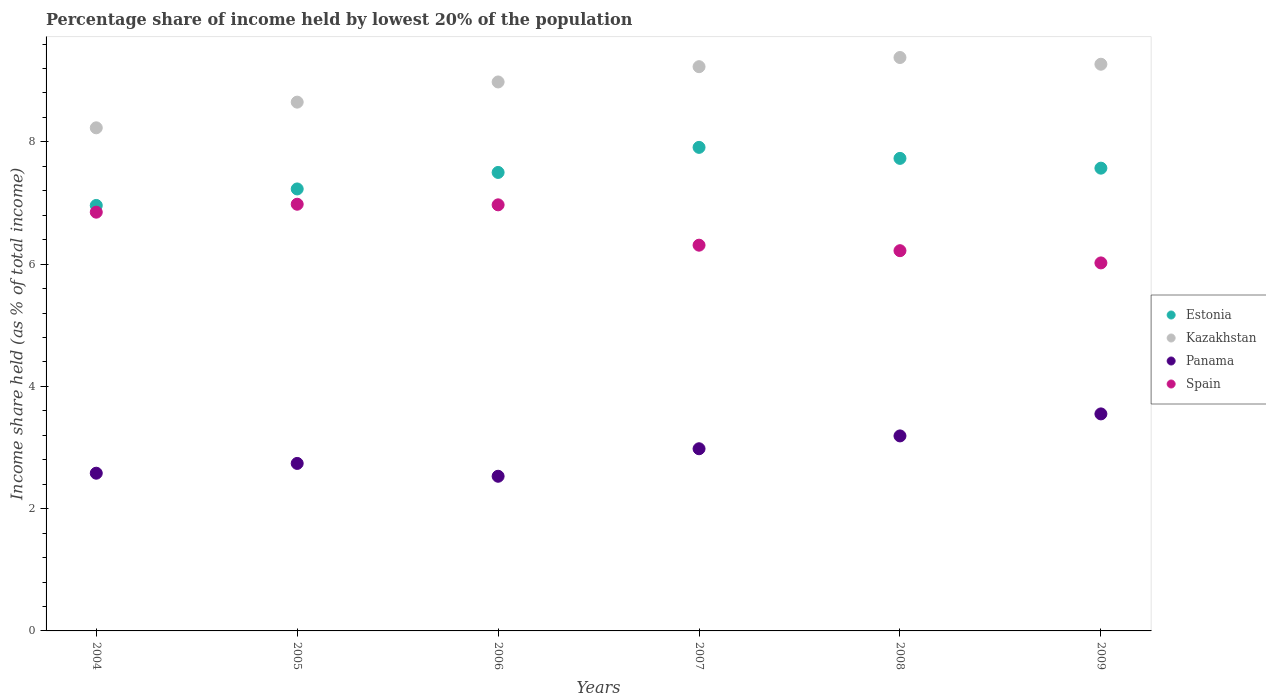Is the number of dotlines equal to the number of legend labels?
Offer a very short reply. Yes. What is the percentage share of income held by lowest 20% of the population in Spain in 2007?
Provide a succinct answer. 6.31. Across all years, what is the maximum percentage share of income held by lowest 20% of the population in Estonia?
Offer a very short reply. 7.91. Across all years, what is the minimum percentage share of income held by lowest 20% of the population in Spain?
Offer a terse response. 6.02. What is the total percentage share of income held by lowest 20% of the population in Estonia in the graph?
Your answer should be compact. 44.9. What is the difference between the percentage share of income held by lowest 20% of the population in Spain in 2004 and that in 2008?
Your answer should be compact. 0.63. What is the difference between the percentage share of income held by lowest 20% of the population in Kazakhstan in 2006 and the percentage share of income held by lowest 20% of the population in Estonia in 2004?
Give a very brief answer. 2.02. What is the average percentage share of income held by lowest 20% of the population in Kazakhstan per year?
Give a very brief answer. 8.96. In the year 2006, what is the difference between the percentage share of income held by lowest 20% of the population in Estonia and percentage share of income held by lowest 20% of the population in Panama?
Your answer should be very brief. 4.97. In how many years, is the percentage share of income held by lowest 20% of the population in Estonia greater than 5.2 %?
Provide a short and direct response. 6. What is the ratio of the percentage share of income held by lowest 20% of the population in Spain in 2005 to that in 2009?
Make the answer very short. 1.16. Is the difference between the percentage share of income held by lowest 20% of the population in Estonia in 2005 and 2008 greater than the difference between the percentage share of income held by lowest 20% of the population in Panama in 2005 and 2008?
Give a very brief answer. No. What is the difference between the highest and the second highest percentage share of income held by lowest 20% of the population in Panama?
Offer a terse response. 0.36. What is the difference between the highest and the lowest percentage share of income held by lowest 20% of the population in Panama?
Provide a succinct answer. 1.02. In how many years, is the percentage share of income held by lowest 20% of the population in Kazakhstan greater than the average percentage share of income held by lowest 20% of the population in Kazakhstan taken over all years?
Your response must be concise. 4. Is it the case that in every year, the sum of the percentage share of income held by lowest 20% of the population in Kazakhstan and percentage share of income held by lowest 20% of the population in Spain  is greater than the sum of percentage share of income held by lowest 20% of the population in Estonia and percentage share of income held by lowest 20% of the population in Panama?
Make the answer very short. Yes. Is it the case that in every year, the sum of the percentage share of income held by lowest 20% of the population in Panama and percentage share of income held by lowest 20% of the population in Kazakhstan  is greater than the percentage share of income held by lowest 20% of the population in Estonia?
Your answer should be compact. Yes. Does the percentage share of income held by lowest 20% of the population in Estonia monotonically increase over the years?
Ensure brevity in your answer.  No. Is the percentage share of income held by lowest 20% of the population in Kazakhstan strictly greater than the percentage share of income held by lowest 20% of the population in Panama over the years?
Your answer should be very brief. Yes. How many dotlines are there?
Ensure brevity in your answer.  4. How many years are there in the graph?
Offer a very short reply. 6. Are the values on the major ticks of Y-axis written in scientific E-notation?
Give a very brief answer. No. Does the graph contain any zero values?
Your answer should be very brief. No. Does the graph contain grids?
Give a very brief answer. No. How many legend labels are there?
Your response must be concise. 4. What is the title of the graph?
Keep it short and to the point. Percentage share of income held by lowest 20% of the population. Does "Macedonia" appear as one of the legend labels in the graph?
Give a very brief answer. No. What is the label or title of the X-axis?
Your response must be concise. Years. What is the label or title of the Y-axis?
Your answer should be compact. Income share held (as % of total income). What is the Income share held (as % of total income) of Estonia in 2004?
Offer a very short reply. 6.96. What is the Income share held (as % of total income) of Kazakhstan in 2004?
Provide a short and direct response. 8.23. What is the Income share held (as % of total income) in Panama in 2004?
Offer a very short reply. 2.58. What is the Income share held (as % of total income) of Spain in 2004?
Offer a terse response. 6.85. What is the Income share held (as % of total income) in Estonia in 2005?
Your response must be concise. 7.23. What is the Income share held (as % of total income) in Kazakhstan in 2005?
Ensure brevity in your answer.  8.65. What is the Income share held (as % of total income) in Panama in 2005?
Your answer should be compact. 2.74. What is the Income share held (as % of total income) of Spain in 2005?
Your response must be concise. 6.98. What is the Income share held (as % of total income) in Kazakhstan in 2006?
Keep it short and to the point. 8.98. What is the Income share held (as % of total income) of Panama in 2006?
Your response must be concise. 2.53. What is the Income share held (as % of total income) of Spain in 2006?
Provide a succinct answer. 6.97. What is the Income share held (as % of total income) in Estonia in 2007?
Your answer should be compact. 7.91. What is the Income share held (as % of total income) in Kazakhstan in 2007?
Your answer should be compact. 9.23. What is the Income share held (as % of total income) in Panama in 2007?
Ensure brevity in your answer.  2.98. What is the Income share held (as % of total income) in Spain in 2007?
Offer a terse response. 6.31. What is the Income share held (as % of total income) in Estonia in 2008?
Offer a terse response. 7.73. What is the Income share held (as % of total income) of Kazakhstan in 2008?
Give a very brief answer. 9.38. What is the Income share held (as % of total income) of Panama in 2008?
Make the answer very short. 3.19. What is the Income share held (as % of total income) in Spain in 2008?
Your answer should be compact. 6.22. What is the Income share held (as % of total income) of Estonia in 2009?
Ensure brevity in your answer.  7.57. What is the Income share held (as % of total income) in Kazakhstan in 2009?
Make the answer very short. 9.27. What is the Income share held (as % of total income) in Panama in 2009?
Offer a very short reply. 3.55. What is the Income share held (as % of total income) in Spain in 2009?
Your answer should be compact. 6.02. Across all years, what is the maximum Income share held (as % of total income) of Estonia?
Give a very brief answer. 7.91. Across all years, what is the maximum Income share held (as % of total income) of Kazakhstan?
Your answer should be very brief. 9.38. Across all years, what is the maximum Income share held (as % of total income) in Panama?
Make the answer very short. 3.55. Across all years, what is the maximum Income share held (as % of total income) of Spain?
Give a very brief answer. 6.98. Across all years, what is the minimum Income share held (as % of total income) in Estonia?
Keep it short and to the point. 6.96. Across all years, what is the minimum Income share held (as % of total income) in Kazakhstan?
Offer a terse response. 8.23. Across all years, what is the minimum Income share held (as % of total income) in Panama?
Offer a terse response. 2.53. Across all years, what is the minimum Income share held (as % of total income) in Spain?
Your answer should be compact. 6.02. What is the total Income share held (as % of total income) of Estonia in the graph?
Provide a short and direct response. 44.9. What is the total Income share held (as % of total income) in Kazakhstan in the graph?
Make the answer very short. 53.74. What is the total Income share held (as % of total income) of Panama in the graph?
Provide a succinct answer. 17.57. What is the total Income share held (as % of total income) in Spain in the graph?
Provide a succinct answer. 39.35. What is the difference between the Income share held (as % of total income) in Estonia in 2004 and that in 2005?
Ensure brevity in your answer.  -0.27. What is the difference between the Income share held (as % of total income) of Kazakhstan in 2004 and that in 2005?
Keep it short and to the point. -0.42. What is the difference between the Income share held (as % of total income) in Panama in 2004 and that in 2005?
Your response must be concise. -0.16. What is the difference between the Income share held (as % of total income) of Spain in 2004 and that in 2005?
Provide a succinct answer. -0.13. What is the difference between the Income share held (as % of total income) of Estonia in 2004 and that in 2006?
Provide a succinct answer. -0.54. What is the difference between the Income share held (as % of total income) of Kazakhstan in 2004 and that in 2006?
Keep it short and to the point. -0.75. What is the difference between the Income share held (as % of total income) in Spain in 2004 and that in 2006?
Ensure brevity in your answer.  -0.12. What is the difference between the Income share held (as % of total income) in Estonia in 2004 and that in 2007?
Ensure brevity in your answer.  -0.95. What is the difference between the Income share held (as % of total income) of Kazakhstan in 2004 and that in 2007?
Provide a succinct answer. -1. What is the difference between the Income share held (as % of total income) in Spain in 2004 and that in 2007?
Keep it short and to the point. 0.54. What is the difference between the Income share held (as % of total income) of Estonia in 2004 and that in 2008?
Provide a succinct answer. -0.77. What is the difference between the Income share held (as % of total income) of Kazakhstan in 2004 and that in 2008?
Ensure brevity in your answer.  -1.15. What is the difference between the Income share held (as % of total income) in Panama in 2004 and that in 2008?
Offer a terse response. -0.61. What is the difference between the Income share held (as % of total income) of Spain in 2004 and that in 2008?
Offer a very short reply. 0.63. What is the difference between the Income share held (as % of total income) in Estonia in 2004 and that in 2009?
Your response must be concise. -0.61. What is the difference between the Income share held (as % of total income) of Kazakhstan in 2004 and that in 2009?
Keep it short and to the point. -1.04. What is the difference between the Income share held (as % of total income) in Panama in 2004 and that in 2009?
Provide a succinct answer. -0.97. What is the difference between the Income share held (as % of total income) in Spain in 2004 and that in 2009?
Provide a short and direct response. 0.83. What is the difference between the Income share held (as % of total income) of Estonia in 2005 and that in 2006?
Provide a short and direct response. -0.27. What is the difference between the Income share held (as % of total income) of Kazakhstan in 2005 and that in 2006?
Make the answer very short. -0.33. What is the difference between the Income share held (as % of total income) in Panama in 2005 and that in 2006?
Your answer should be compact. 0.21. What is the difference between the Income share held (as % of total income) of Estonia in 2005 and that in 2007?
Your answer should be very brief. -0.68. What is the difference between the Income share held (as % of total income) in Kazakhstan in 2005 and that in 2007?
Your answer should be very brief. -0.58. What is the difference between the Income share held (as % of total income) of Panama in 2005 and that in 2007?
Ensure brevity in your answer.  -0.24. What is the difference between the Income share held (as % of total income) of Spain in 2005 and that in 2007?
Provide a succinct answer. 0.67. What is the difference between the Income share held (as % of total income) in Kazakhstan in 2005 and that in 2008?
Give a very brief answer. -0.73. What is the difference between the Income share held (as % of total income) of Panama in 2005 and that in 2008?
Give a very brief answer. -0.45. What is the difference between the Income share held (as % of total income) in Spain in 2005 and that in 2008?
Ensure brevity in your answer.  0.76. What is the difference between the Income share held (as % of total income) in Estonia in 2005 and that in 2009?
Your response must be concise. -0.34. What is the difference between the Income share held (as % of total income) in Kazakhstan in 2005 and that in 2009?
Your answer should be compact. -0.62. What is the difference between the Income share held (as % of total income) of Panama in 2005 and that in 2009?
Offer a very short reply. -0.81. What is the difference between the Income share held (as % of total income) of Spain in 2005 and that in 2009?
Offer a very short reply. 0.96. What is the difference between the Income share held (as % of total income) in Estonia in 2006 and that in 2007?
Make the answer very short. -0.41. What is the difference between the Income share held (as % of total income) of Panama in 2006 and that in 2007?
Offer a terse response. -0.45. What is the difference between the Income share held (as % of total income) of Spain in 2006 and that in 2007?
Your response must be concise. 0.66. What is the difference between the Income share held (as % of total income) in Estonia in 2006 and that in 2008?
Your answer should be compact. -0.23. What is the difference between the Income share held (as % of total income) of Kazakhstan in 2006 and that in 2008?
Offer a very short reply. -0.4. What is the difference between the Income share held (as % of total income) of Panama in 2006 and that in 2008?
Ensure brevity in your answer.  -0.66. What is the difference between the Income share held (as % of total income) of Estonia in 2006 and that in 2009?
Keep it short and to the point. -0.07. What is the difference between the Income share held (as % of total income) of Kazakhstan in 2006 and that in 2009?
Offer a terse response. -0.29. What is the difference between the Income share held (as % of total income) in Panama in 2006 and that in 2009?
Provide a short and direct response. -1.02. What is the difference between the Income share held (as % of total income) in Spain in 2006 and that in 2009?
Offer a very short reply. 0.95. What is the difference between the Income share held (as % of total income) of Estonia in 2007 and that in 2008?
Provide a short and direct response. 0.18. What is the difference between the Income share held (as % of total income) in Panama in 2007 and that in 2008?
Offer a terse response. -0.21. What is the difference between the Income share held (as % of total income) of Spain in 2007 and that in 2008?
Offer a very short reply. 0.09. What is the difference between the Income share held (as % of total income) in Estonia in 2007 and that in 2009?
Keep it short and to the point. 0.34. What is the difference between the Income share held (as % of total income) of Kazakhstan in 2007 and that in 2009?
Make the answer very short. -0.04. What is the difference between the Income share held (as % of total income) of Panama in 2007 and that in 2009?
Provide a succinct answer. -0.57. What is the difference between the Income share held (as % of total income) of Spain in 2007 and that in 2009?
Provide a succinct answer. 0.29. What is the difference between the Income share held (as % of total income) in Estonia in 2008 and that in 2009?
Offer a very short reply. 0.16. What is the difference between the Income share held (as % of total income) of Kazakhstan in 2008 and that in 2009?
Keep it short and to the point. 0.11. What is the difference between the Income share held (as % of total income) in Panama in 2008 and that in 2009?
Keep it short and to the point. -0.36. What is the difference between the Income share held (as % of total income) in Estonia in 2004 and the Income share held (as % of total income) in Kazakhstan in 2005?
Your response must be concise. -1.69. What is the difference between the Income share held (as % of total income) of Estonia in 2004 and the Income share held (as % of total income) of Panama in 2005?
Your answer should be compact. 4.22. What is the difference between the Income share held (as % of total income) of Estonia in 2004 and the Income share held (as % of total income) of Spain in 2005?
Give a very brief answer. -0.02. What is the difference between the Income share held (as % of total income) in Kazakhstan in 2004 and the Income share held (as % of total income) in Panama in 2005?
Give a very brief answer. 5.49. What is the difference between the Income share held (as % of total income) of Panama in 2004 and the Income share held (as % of total income) of Spain in 2005?
Give a very brief answer. -4.4. What is the difference between the Income share held (as % of total income) in Estonia in 2004 and the Income share held (as % of total income) in Kazakhstan in 2006?
Give a very brief answer. -2.02. What is the difference between the Income share held (as % of total income) in Estonia in 2004 and the Income share held (as % of total income) in Panama in 2006?
Your response must be concise. 4.43. What is the difference between the Income share held (as % of total income) in Estonia in 2004 and the Income share held (as % of total income) in Spain in 2006?
Provide a succinct answer. -0.01. What is the difference between the Income share held (as % of total income) in Kazakhstan in 2004 and the Income share held (as % of total income) in Panama in 2006?
Your response must be concise. 5.7. What is the difference between the Income share held (as % of total income) of Kazakhstan in 2004 and the Income share held (as % of total income) of Spain in 2006?
Keep it short and to the point. 1.26. What is the difference between the Income share held (as % of total income) in Panama in 2004 and the Income share held (as % of total income) in Spain in 2006?
Provide a succinct answer. -4.39. What is the difference between the Income share held (as % of total income) in Estonia in 2004 and the Income share held (as % of total income) in Kazakhstan in 2007?
Your answer should be compact. -2.27. What is the difference between the Income share held (as % of total income) of Estonia in 2004 and the Income share held (as % of total income) of Panama in 2007?
Offer a terse response. 3.98. What is the difference between the Income share held (as % of total income) in Estonia in 2004 and the Income share held (as % of total income) in Spain in 2007?
Offer a terse response. 0.65. What is the difference between the Income share held (as % of total income) in Kazakhstan in 2004 and the Income share held (as % of total income) in Panama in 2007?
Keep it short and to the point. 5.25. What is the difference between the Income share held (as % of total income) of Kazakhstan in 2004 and the Income share held (as % of total income) of Spain in 2007?
Offer a terse response. 1.92. What is the difference between the Income share held (as % of total income) in Panama in 2004 and the Income share held (as % of total income) in Spain in 2007?
Your response must be concise. -3.73. What is the difference between the Income share held (as % of total income) in Estonia in 2004 and the Income share held (as % of total income) in Kazakhstan in 2008?
Your answer should be very brief. -2.42. What is the difference between the Income share held (as % of total income) in Estonia in 2004 and the Income share held (as % of total income) in Panama in 2008?
Offer a very short reply. 3.77. What is the difference between the Income share held (as % of total income) in Estonia in 2004 and the Income share held (as % of total income) in Spain in 2008?
Provide a short and direct response. 0.74. What is the difference between the Income share held (as % of total income) in Kazakhstan in 2004 and the Income share held (as % of total income) in Panama in 2008?
Your answer should be compact. 5.04. What is the difference between the Income share held (as % of total income) in Kazakhstan in 2004 and the Income share held (as % of total income) in Spain in 2008?
Your answer should be compact. 2.01. What is the difference between the Income share held (as % of total income) in Panama in 2004 and the Income share held (as % of total income) in Spain in 2008?
Offer a terse response. -3.64. What is the difference between the Income share held (as % of total income) of Estonia in 2004 and the Income share held (as % of total income) of Kazakhstan in 2009?
Offer a terse response. -2.31. What is the difference between the Income share held (as % of total income) in Estonia in 2004 and the Income share held (as % of total income) in Panama in 2009?
Your answer should be compact. 3.41. What is the difference between the Income share held (as % of total income) in Kazakhstan in 2004 and the Income share held (as % of total income) in Panama in 2009?
Provide a short and direct response. 4.68. What is the difference between the Income share held (as % of total income) in Kazakhstan in 2004 and the Income share held (as % of total income) in Spain in 2009?
Your response must be concise. 2.21. What is the difference between the Income share held (as % of total income) of Panama in 2004 and the Income share held (as % of total income) of Spain in 2009?
Ensure brevity in your answer.  -3.44. What is the difference between the Income share held (as % of total income) in Estonia in 2005 and the Income share held (as % of total income) in Kazakhstan in 2006?
Provide a succinct answer. -1.75. What is the difference between the Income share held (as % of total income) of Estonia in 2005 and the Income share held (as % of total income) of Panama in 2006?
Keep it short and to the point. 4.7. What is the difference between the Income share held (as % of total income) in Estonia in 2005 and the Income share held (as % of total income) in Spain in 2006?
Give a very brief answer. 0.26. What is the difference between the Income share held (as % of total income) in Kazakhstan in 2005 and the Income share held (as % of total income) in Panama in 2006?
Your response must be concise. 6.12. What is the difference between the Income share held (as % of total income) of Kazakhstan in 2005 and the Income share held (as % of total income) of Spain in 2006?
Provide a succinct answer. 1.68. What is the difference between the Income share held (as % of total income) of Panama in 2005 and the Income share held (as % of total income) of Spain in 2006?
Your answer should be very brief. -4.23. What is the difference between the Income share held (as % of total income) of Estonia in 2005 and the Income share held (as % of total income) of Panama in 2007?
Make the answer very short. 4.25. What is the difference between the Income share held (as % of total income) of Kazakhstan in 2005 and the Income share held (as % of total income) of Panama in 2007?
Offer a terse response. 5.67. What is the difference between the Income share held (as % of total income) in Kazakhstan in 2005 and the Income share held (as % of total income) in Spain in 2007?
Give a very brief answer. 2.34. What is the difference between the Income share held (as % of total income) of Panama in 2005 and the Income share held (as % of total income) of Spain in 2007?
Your answer should be very brief. -3.57. What is the difference between the Income share held (as % of total income) of Estonia in 2005 and the Income share held (as % of total income) of Kazakhstan in 2008?
Your answer should be compact. -2.15. What is the difference between the Income share held (as % of total income) in Estonia in 2005 and the Income share held (as % of total income) in Panama in 2008?
Offer a very short reply. 4.04. What is the difference between the Income share held (as % of total income) of Kazakhstan in 2005 and the Income share held (as % of total income) of Panama in 2008?
Offer a terse response. 5.46. What is the difference between the Income share held (as % of total income) in Kazakhstan in 2005 and the Income share held (as % of total income) in Spain in 2008?
Offer a terse response. 2.43. What is the difference between the Income share held (as % of total income) of Panama in 2005 and the Income share held (as % of total income) of Spain in 2008?
Give a very brief answer. -3.48. What is the difference between the Income share held (as % of total income) of Estonia in 2005 and the Income share held (as % of total income) of Kazakhstan in 2009?
Keep it short and to the point. -2.04. What is the difference between the Income share held (as % of total income) of Estonia in 2005 and the Income share held (as % of total income) of Panama in 2009?
Offer a terse response. 3.68. What is the difference between the Income share held (as % of total income) of Estonia in 2005 and the Income share held (as % of total income) of Spain in 2009?
Offer a terse response. 1.21. What is the difference between the Income share held (as % of total income) of Kazakhstan in 2005 and the Income share held (as % of total income) of Spain in 2009?
Ensure brevity in your answer.  2.63. What is the difference between the Income share held (as % of total income) in Panama in 2005 and the Income share held (as % of total income) in Spain in 2009?
Offer a terse response. -3.28. What is the difference between the Income share held (as % of total income) of Estonia in 2006 and the Income share held (as % of total income) of Kazakhstan in 2007?
Your answer should be very brief. -1.73. What is the difference between the Income share held (as % of total income) of Estonia in 2006 and the Income share held (as % of total income) of Panama in 2007?
Ensure brevity in your answer.  4.52. What is the difference between the Income share held (as % of total income) in Estonia in 2006 and the Income share held (as % of total income) in Spain in 2007?
Your answer should be compact. 1.19. What is the difference between the Income share held (as % of total income) of Kazakhstan in 2006 and the Income share held (as % of total income) of Spain in 2007?
Give a very brief answer. 2.67. What is the difference between the Income share held (as % of total income) of Panama in 2006 and the Income share held (as % of total income) of Spain in 2007?
Offer a very short reply. -3.78. What is the difference between the Income share held (as % of total income) of Estonia in 2006 and the Income share held (as % of total income) of Kazakhstan in 2008?
Your answer should be compact. -1.88. What is the difference between the Income share held (as % of total income) in Estonia in 2006 and the Income share held (as % of total income) in Panama in 2008?
Your answer should be compact. 4.31. What is the difference between the Income share held (as % of total income) in Estonia in 2006 and the Income share held (as % of total income) in Spain in 2008?
Make the answer very short. 1.28. What is the difference between the Income share held (as % of total income) of Kazakhstan in 2006 and the Income share held (as % of total income) of Panama in 2008?
Your answer should be very brief. 5.79. What is the difference between the Income share held (as % of total income) of Kazakhstan in 2006 and the Income share held (as % of total income) of Spain in 2008?
Make the answer very short. 2.76. What is the difference between the Income share held (as % of total income) of Panama in 2006 and the Income share held (as % of total income) of Spain in 2008?
Offer a very short reply. -3.69. What is the difference between the Income share held (as % of total income) of Estonia in 2006 and the Income share held (as % of total income) of Kazakhstan in 2009?
Provide a succinct answer. -1.77. What is the difference between the Income share held (as % of total income) in Estonia in 2006 and the Income share held (as % of total income) in Panama in 2009?
Give a very brief answer. 3.95. What is the difference between the Income share held (as % of total income) in Estonia in 2006 and the Income share held (as % of total income) in Spain in 2009?
Provide a succinct answer. 1.48. What is the difference between the Income share held (as % of total income) of Kazakhstan in 2006 and the Income share held (as % of total income) of Panama in 2009?
Provide a short and direct response. 5.43. What is the difference between the Income share held (as % of total income) of Kazakhstan in 2006 and the Income share held (as % of total income) of Spain in 2009?
Give a very brief answer. 2.96. What is the difference between the Income share held (as % of total income) of Panama in 2006 and the Income share held (as % of total income) of Spain in 2009?
Ensure brevity in your answer.  -3.49. What is the difference between the Income share held (as % of total income) of Estonia in 2007 and the Income share held (as % of total income) of Kazakhstan in 2008?
Provide a succinct answer. -1.47. What is the difference between the Income share held (as % of total income) of Estonia in 2007 and the Income share held (as % of total income) of Panama in 2008?
Offer a terse response. 4.72. What is the difference between the Income share held (as % of total income) in Estonia in 2007 and the Income share held (as % of total income) in Spain in 2008?
Keep it short and to the point. 1.69. What is the difference between the Income share held (as % of total income) in Kazakhstan in 2007 and the Income share held (as % of total income) in Panama in 2008?
Your response must be concise. 6.04. What is the difference between the Income share held (as % of total income) in Kazakhstan in 2007 and the Income share held (as % of total income) in Spain in 2008?
Your answer should be very brief. 3.01. What is the difference between the Income share held (as % of total income) in Panama in 2007 and the Income share held (as % of total income) in Spain in 2008?
Offer a very short reply. -3.24. What is the difference between the Income share held (as % of total income) of Estonia in 2007 and the Income share held (as % of total income) of Kazakhstan in 2009?
Your answer should be very brief. -1.36. What is the difference between the Income share held (as % of total income) in Estonia in 2007 and the Income share held (as % of total income) in Panama in 2009?
Ensure brevity in your answer.  4.36. What is the difference between the Income share held (as % of total income) of Estonia in 2007 and the Income share held (as % of total income) of Spain in 2009?
Make the answer very short. 1.89. What is the difference between the Income share held (as % of total income) of Kazakhstan in 2007 and the Income share held (as % of total income) of Panama in 2009?
Ensure brevity in your answer.  5.68. What is the difference between the Income share held (as % of total income) of Kazakhstan in 2007 and the Income share held (as % of total income) of Spain in 2009?
Offer a very short reply. 3.21. What is the difference between the Income share held (as % of total income) in Panama in 2007 and the Income share held (as % of total income) in Spain in 2009?
Provide a short and direct response. -3.04. What is the difference between the Income share held (as % of total income) in Estonia in 2008 and the Income share held (as % of total income) in Kazakhstan in 2009?
Keep it short and to the point. -1.54. What is the difference between the Income share held (as % of total income) of Estonia in 2008 and the Income share held (as % of total income) of Panama in 2009?
Your answer should be very brief. 4.18. What is the difference between the Income share held (as % of total income) of Estonia in 2008 and the Income share held (as % of total income) of Spain in 2009?
Give a very brief answer. 1.71. What is the difference between the Income share held (as % of total income) of Kazakhstan in 2008 and the Income share held (as % of total income) of Panama in 2009?
Keep it short and to the point. 5.83. What is the difference between the Income share held (as % of total income) in Kazakhstan in 2008 and the Income share held (as % of total income) in Spain in 2009?
Ensure brevity in your answer.  3.36. What is the difference between the Income share held (as % of total income) in Panama in 2008 and the Income share held (as % of total income) in Spain in 2009?
Your answer should be very brief. -2.83. What is the average Income share held (as % of total income) of Estonia per year?
Your response must be concise. 7.48. What is the average Income share held (as % of total income) in Kazakhstan per year?
Your answer should be compact. 8.96. What is the average Income share held (as % of total income) in Panama per year?
Offer a very short reply. 2.93. What is the average Income share held (as % of total income) of Spain per year?
Your response must be concise. 6.56. In the year 2004, what is the difference between the Income share held (as % of total income) of Estonia and Income share held (as % of total income) of Kazakhstan?
Offer a terse response. -1.27. In the year 2004, what is the difference between the Income share held (as % of total income) of Estonia and Income share held (as % of total income) of Panama?
Your answer should be very brief. 4.38. In the year 2004, what is the difference between the Income share held (as % of total income) in Estonia and Income share held (as % of total income) in Spain?
Provide a short and direct response. 0.11. In the year 2004, what is the difference between the Income share held (as % of total income) in Kazakhstan and Income share held (as % of total income) in Panama?
Offer a terse response. 5.65. In the year 2004, what is the difference between the Income share held (as % of total income) in Kazakhstan and Income share held (as % of total income) in Spain?
Offer a terse response. 1.38. In the year 2004, what is the difference between the Income share held (as % of total income) in Panama and Income share held (as % of total income) in Spain?
Provide a succinct answer. -4.27. In the year 2005, what is the difference between the Income share held (as % of total income) of Estonia and Income share held (as % of total income) of Kazakhstan?
Provide a short and direct response. -1.42. In the year 2005, what is the difference between the Income share held (as % of total income) of Estonia and Income share held (as % of total income) of Panama?
Give a very brief answer. 4.49. In the year 2005, what is the difference between the Income share held (as % of total income) of Kazakhstan and Income share held (as % of total income) of Panama?
Your answer should be very brief. 5.91. In the year 2005, what is the difference between the Income share held (as % of total income) of Kazakhstan and Income share held (as % of total income) of Spain?
Ensure brevity in your answer.  1.67. In the year 2005, what is the difference between the Income share held (as % of total income) in Panama and Income share held (as % of total income) in Spain?
Ensure brevity in your answer.  -4.24. In the year 2006, what is the difference between the Income share held (as % of total income) of Estonia and Income share held (as % of total income) of Kazakhstan?
Provide a short and direct response. -1.48. In the year 2006, what is the difference between the Income share held (as % of total income) in Estonia and Income share held (as % of total income) in Panama?
Your answer should be very brief. 4.97. In the year 2006, what is the difference between the Income share held (as % of total income) in Estonia and Income share held (as % of total income) in Spain?
Your answer should be very brief. 0.53. In the year 2006, what is the difference between the Income share held (as % of total income) in Kazakhstan and Income share held (as % of total income) in Panama?
Your response must be concise. 6.45. In the year 2006, what is the difference between the Income share held (as % of total income) of Kazakhstan and Income share held (as % of total income) of Spain?
Your answer should be compact. 2.01. In the year 2006, what is the difference between the Income share held (as % of total income) in Panama and Income share held (as % of total income) in Spain?
Provide a short and direct response. -4.44. In the year 2007, what is the difference between the Income share held (as % of total income) in Estonia and Income share held (as % of total income) in Kazakhstan?
Your answer should be very brief. -1.32. In the year 2007, what is the difference between the Income share held (as % of total income) in Estonia and Income share held (as % of total income) in Panama?
Make the answer very short. 4.93. In the year 2007, what is the difference between the Income share held (as % of total income) in Estonia and Income share held (as % of total income) in Spain?
Your answer should be compact. 1.6. In the year 2007, what is the difference between the Income share held (as % of total income) of Kazakhstan and Income share held (as % of total income) of Panama?
Your response must be concise. 6.25. In the year 2007, what is the difference between the Income share held (as % of total income) of Kazakhstan and Income share held (as % of total income) of Spain?
Offer a terse response. 2.92. In the year 2007, what is the difference between the Income share held (as % of total income) of Panama and Income share held (as % of total income) of Spain?
Keep it short and to the point. -3.33. In the year 2008, what is the difference between the Income share held (as % of total income) of Estonia and Income share held (as % of total income) of Kazakhstan?
Provide a succinct answer. -1.65. In the year 2008, what is the difference between the Income share held (as % of total income) in Estonia and Income share held (as % of total income) in Panama?
Your answer should be compact. 4.54. In the year 2008, what is the difference between the Income share held (as % of total income) in Estonia and Income share held (as % of total income) in Spain?
Your answer should be very brief. 1.51. In the year 2008, what is the difference between the Income share held (as % of total income) in Kazakhstan and Income share held (as % of total income) in Panama?
Make the answer very short. 6.19. In the year 2008, what is the difference between the Income share held (as % of total income) of Kazakhstan and Income share held (as % of total income) of Spain?
Provide a succinct answer. 3.16. In the year 2008, what is the difference between the Income share held (as % of total income) in Panama and Income share held (as % of total income) in Spain?
Offer a terse response. -3.03. In the year 2009, what is the difference between the Income share held (as % of total income) in Estonia and Income share held (as % of total income) in Panama?
Ensure brevity in your answer.  4.02. In the year 2009, what is the difference between the Income share held (as % of total income) of Estonia and Income share held (as % of total income) of Spain?
Ensure brevity in your answer.  1.55. In the year 2009, what is the difference between the Income share held (as % of total income) in Kazakhstan and Income share held (as % of total income) in Panama?
Offer a very short reply. 5.72. In the year 2009, what is the difference between the Income share held (as % of total income) of Panama and Income share held (as % of total income) of Spain?
Offer a very short reply. -2.47. What is the ratio of the Income share held (as % of total income) of Estonia in 2004 to that in 2005?
Keep it short and to the point. 0.96. What is the ratio of the Income share held (as % of total income) in Kazakhstan in 2004 to that in 2005?
Ensure brevity in your answer.  0.95. What is the ratio of the Income share held (as % of total income) of Panama in 2004 to that in 2005?
Your response must be concise. 0.94. What is the ratio of the Income share held (as % of total income) of Spain in 2004 to that in 2005?
Ensure brevity in your answer.  0.98. What is the ratio of the Income share held (as % of total income) in Estonia in 2004 to that in 2006?
Offer a very short reply. 0.93. What is the ratio of the Income share held (as % of total income) in Kazakhstan in 2004 to that in 2006?
Your answer should be very brief. 0.92. What is the ratio of the Income share held (as % of total income) in Panama in 2004 to that in 2006?
Your response must be concise. 1.02. What is the ratio of the Income share held (as % of total income) of Spain in 2004 to that in 2006?
Make the answer very short. 0.98. What is the ratio of the Income share held (as % of total income) of Estonia in 2004 to that in 2007?
Offer a very short reply. 0.88. What is the ratio of the Income share held (as % of total income) of Kazakhstan in 2004 to that in 2007?
Give a very brief answer. 0.89. What is the ratio of the Income share held (as % of total income) of Panama in 2004 to that in 2007?
Provide a succinct answer. 0.87. What is the ratio of the Income share held (as % of total income) in Spain in 2004 to that in 2007?
Your response must be concise. 1.09. What is the ratio of the Income share held (as % of total income) of Estonia in 2004 to that in 2008?
Offer a very short reply. 0.9. What is the ratio of the Income share held (as % of total income) in Kazakhstan in 2004 to that in 2008?
Give a very brief answer. 0.88. What is the ratio of the Income share held (as % of total income) in Panama in 2004 to that in 2008?
Keep it short and to the point. 0.81. What is the ratio of the Income share held (as % of total income) in Spain in 2004 to that in 2008?
Your answer should be very brief. 1.1. What is the ratio of the Income share held (as % of total income) of Estonia in 2004 to that in 2009?
Provide a short and direct response. 0.92. What is the ratio of the Income share held (as % of total income) of Kazakhstan in 2004 to that in 2009?
Make the answer very short. 0.89. What is the ratio of the Income share held (as % of total income) of Panama in 2004 to that in 2009?
Your response must be concise. 0.73. What is the ratio of the Income share held (as % of total income) in Spain in 2004 to that in 2009?
Keep it short and to the point. 1.14. What is the ratio of the Income share held (as % of total income) in Kazakhstan in 2005 to that in 2006?
Offer a terse response. 0.96. What is the ratio of the Income share held (as % of total income) of Panama in 2005 to that in 2006?
Provide a short and direct response. 1.08. What is the ratio of the Income share held (as % of total income) of Estonia in 2005 to that in 2007?
Offer a terse response. 0.91. What is the ratio of the Income share held (as % of total income) of Kazakhstan in 2005 to that in 2007?
Provide a succinct answer. 0.94. What is the ratio of the Income share held (as % of total income) of Panama in 2005 to that in 2007?
Offer a very short reply. 0.92. What is the ratio of the Income share held (as % of total income) in Spain in 2005 to that in 2007?
Offer a terse response. 1.11. What is the ratio of the Income share held (as % of total income) in Estonia in 2005 to that in 2008?
Keep it short and to the point. 0.94. What is the ratio of the Income share held (as % of total income) of Kazakhstan in 2005 to that in 2008?
Your answer should be compact. 0.92. What is the ratio of the Income share held (as % of total income) of Panama in 2005 to that in 2008?
Make the answer very short. 0.86. What is the ratio of the Income share held (as % of total income) in Spain in 2005 to that in 2008?
Provide a short and direct response. 1.12. What is the ratio of the Income share held (as % of total income) in Estonia in 2005 to that in 2009?
Your response must be concise. 0.96. What is the ratio of the Income share held (as % of total income) of Kazakhstan in 2005 to that in 2009?
Your answer should be very brief. 0.93. What is the ratio of the Income share held (as % of total income) of Panama in 2005 to that in 2009?
Your response must be concise. 0.77. What is the ratio of the Income share held (as % of total income) in Spain in 2005 to that in 2009?
Your answer should be very brief. 1.16. What is the ratio of the Income share held (as % of total income) of Estonia in 2006 to that in 2007?
Your answer should be very brief. 0.95. What is the ratio of the Income share held (as % of total income) of Kazakhstan in 2006 to that in 2007?
Your answer should be very brief. 0.97. What is the ratio of the Income share held (as % of total income) of Panama in 2006 to that in 2007?
Give a very brief answer. 0.85. What is the ratio of the Income share held (as % of total income) in Spain in 2006 to that in 2007?
Make the answer very short. 1.1. What is the ratio of the Income share held (as % of total income) of Estonia in 2006 to that in 2008?
Make the answer very short. 0.97. What is the ratio of the Income share held (as % of total income) of Kazakhstan in 2006 to that in 2008?
Offer a very short reply. 0.96. What is the ratio of the Income share held (as % of total income) in Panama in 2006 to that in 2008?
Offer a terse response. 0.79. What is the ratio of the Income share held (as % of total income) in Spain in 2006 to that in 2008?
Ensure brevity in your answer.  1.12. What is the ratio of the Income share held (as % of total income) of Estonia in 2006 to that in 2009?
Ensure brevity in your answer.  0.99. What is the ratio of the Income share held (as % of total income) in Kazakhstan in 2006 to that in 2009?
Ensure brevity in your answer.  0.97. What is the ratio of the Income share held (as % of total income) in Panama in 2006 to that in 2009?
Offer a terse response. 0.71. What is the ratio of the Income share held (as % of total income) in Spain in 2006 to that in 2009?
Offer a very short reply. 1.16. What is the ratio of the Income share held (as % of total income) of Estonia in 2007 to that in 2008?
Make the answer very short. 1.02. What is the ratio of the Income share held (as % of total income) in Panama in 2007 to that in 2008?
Your response must be concise. 0.93. What is the ratio of the Income share held (as % of total income) in Spain in 2007 to that in 2008?
Offer a terse response. 1.01. What is the ratio of the Income share held (as % of total income) in Estonia in 2007 to that in 2009?
Ensure brevity in your answer.  1.04. What is the ratio of the Income share held (as % of total income) of Kazakhstan in 2007 to that in 2009?
Your answer should be compact. 1. What is the ratio of the Income share held (as % of total income) of Panama in 2007 to that in 2009?
Give a very brief answer. 0.84. What is the ratio of the Income share held (as % of total income) in Spain in 2007 to that in 2009?
Offer a terse response. 1.05. What is the ratio of the Income share held (as % of total income) of Estonia in 2008 to that in 2009?
Your answer should be compact. 1.02. What is the ratio of the Income share held (as % of total income) in Kazakhstan in 2008 to that in 2009?
Your answer should be very brief. 1.01. What is the ratio of the Income share held (as % of total income) of Panama in 2008 to that in 2009?
Your response must be concise. 0.9. What is the ratio of the Income share held (as % of total income) of Spain in 2008 to that in 2009?
Give a very brief answer. 1.03. What is the difference between the highest and the second highest Income share held (as % of total income) of Estonia?
Make the answer very short. 0.18. What is the difference between the highest and the second highest Income share held (as % of total income) of Kazakhstan?
Offer a terse response. 0.11. What is the difference between the highest and the second highest Income share held (as % of total income) in Panama?
Your response must be concise. 0.36. What is the difference between the highest and the lowest Income share held (as % of total income) in Estonia?
Offer a terse response. 0.95. What is the difference between the highest and the lowest Income share held (as % of total income) in Kazakhstan?
Provide a succinct answer. 1.15. 